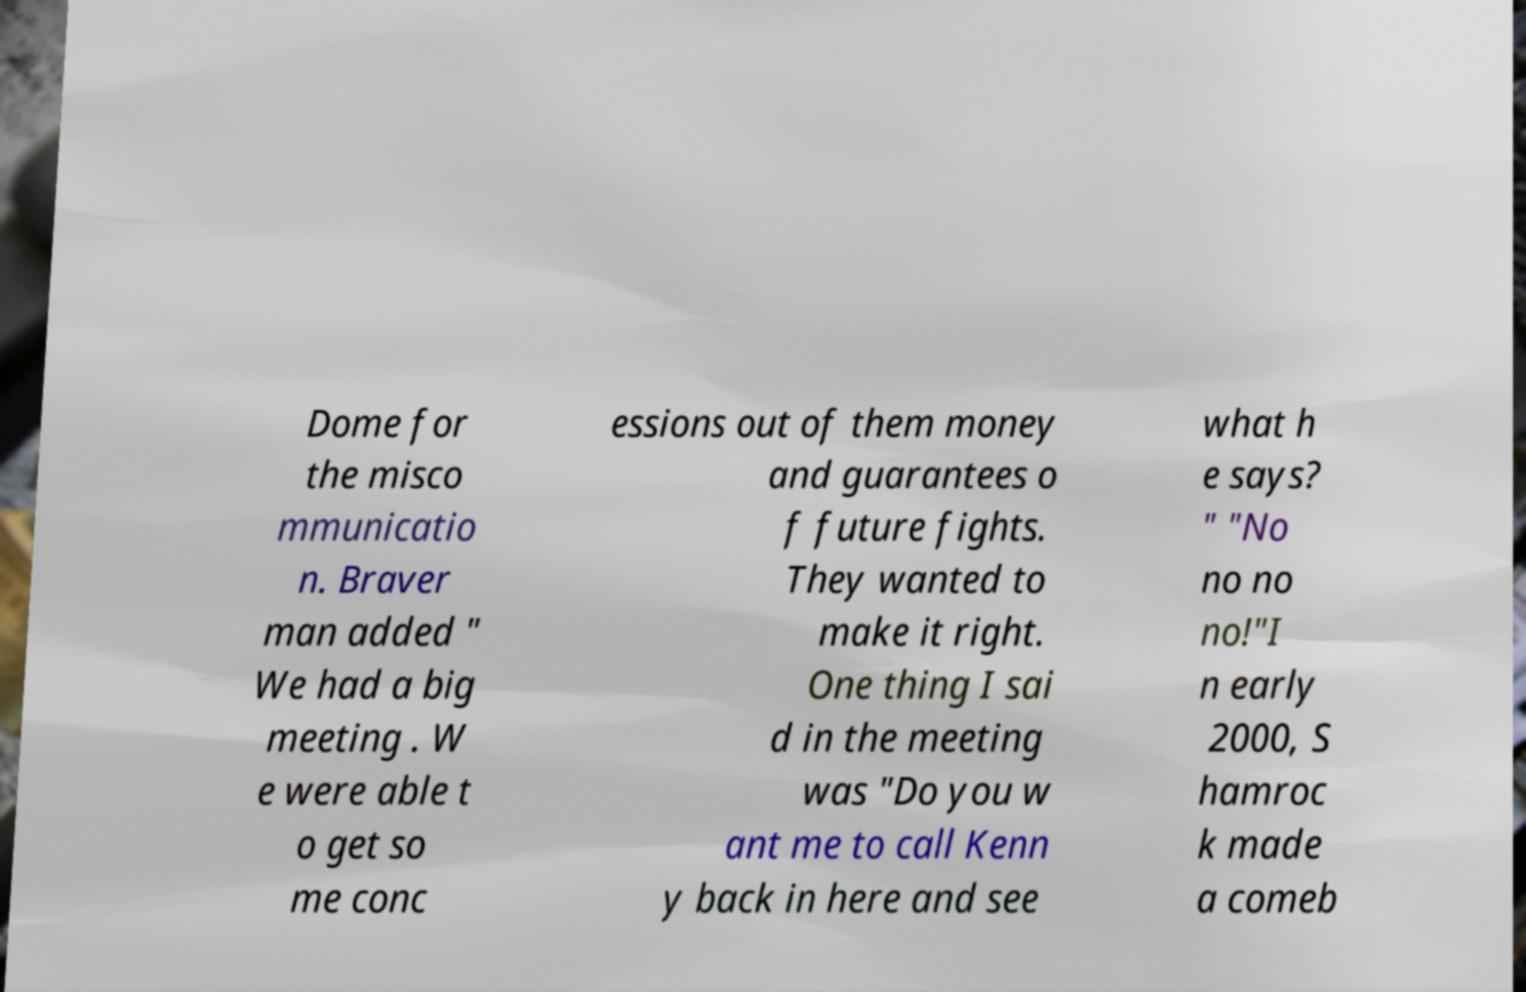Could you assist in decoding the text presented in this image and type it out clearly? Dome for the misco mmunicatio n. Braver man added " We had a big meeting . W e were able t o get so me conc essions out of them money and guarantees o f future fights. They wanted to make it right. One thing I sai d in the meeting was "Do you w ant me to call Kenn y back in here and see what h e says? " "No no no no!"I n early 2000, S hamroc k made a comeb 